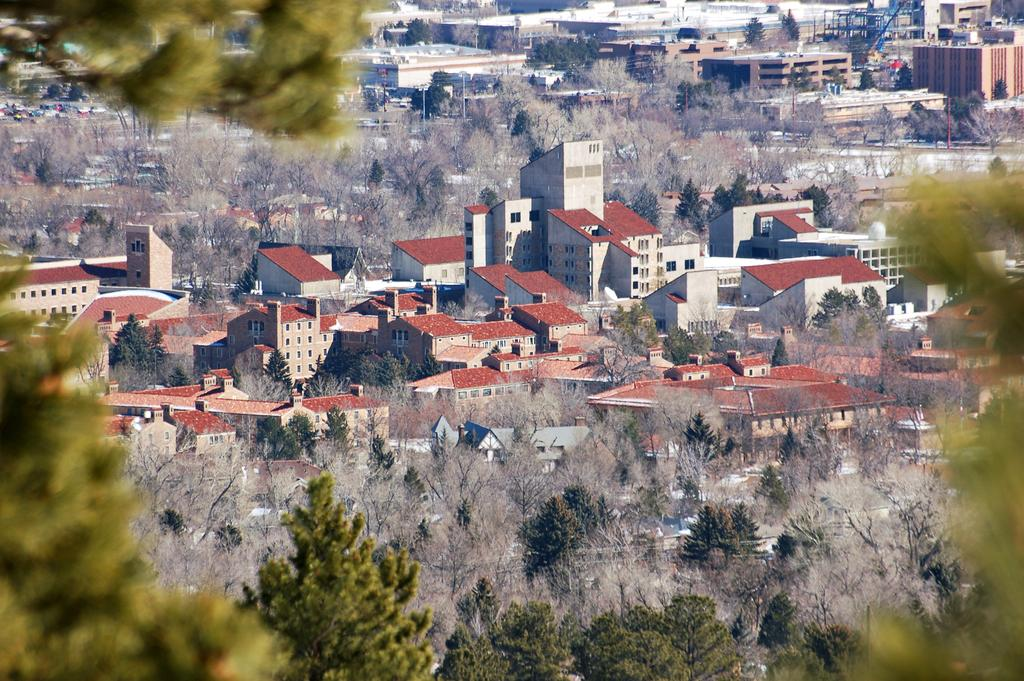What colors are the trees in the image? The trees in the image are green and grey. What colors are the buildings in the image? The buildings in the image are white, maroon, cream, and brown. How does the paste help the trees in the image? There is no paste present in the image, and therefore it cannot help the trees. What type of roll can be seen in the image? There is no roll present in the image. 